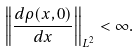Convert formula to latex. <formula><loc_0><loc_0><loc_500><loc_500>\left | \left | \frac { d \rho ( x , 0 ) } { d x } \right | \right | _ { L ^ { 2 } } < \infty .</formula> 